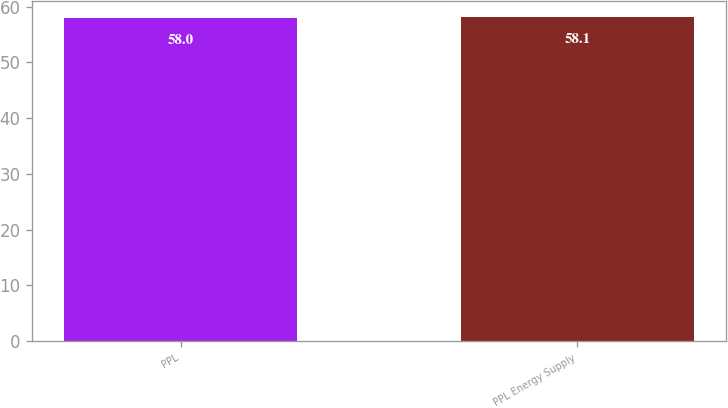Convert chart. <chart><loc_0><loc_0><loc_500><loc_500><bar_chart><fcel>PPL<fcel>PPL Energy Supply<nl><fcel>58<fcel>58.1<nl></chart> 